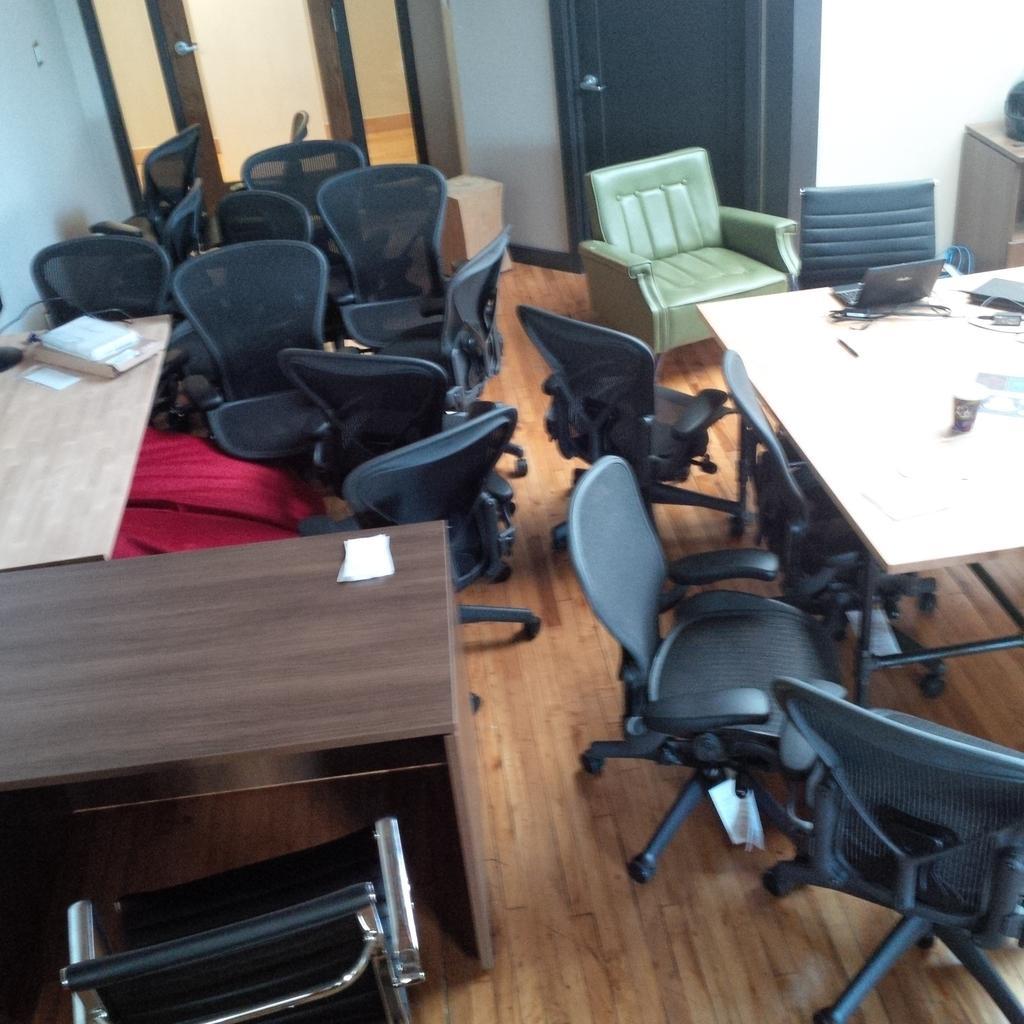Please provide a concise description of this image. This picture is taken in a room. The room is filled with the chairs and tables. On the top right there is a sofa which is in green in color. Behind it there are doors. 